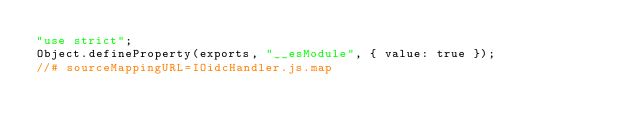Convert code to text. <code><loc_0><loc_0><loc_500><loc_500><_JavaScript_>"use strict";
Object.defineProperty(exports, "__esModule", { value: true });
//# sourceMappingURL=IOidcHandler.js.map
</code> 